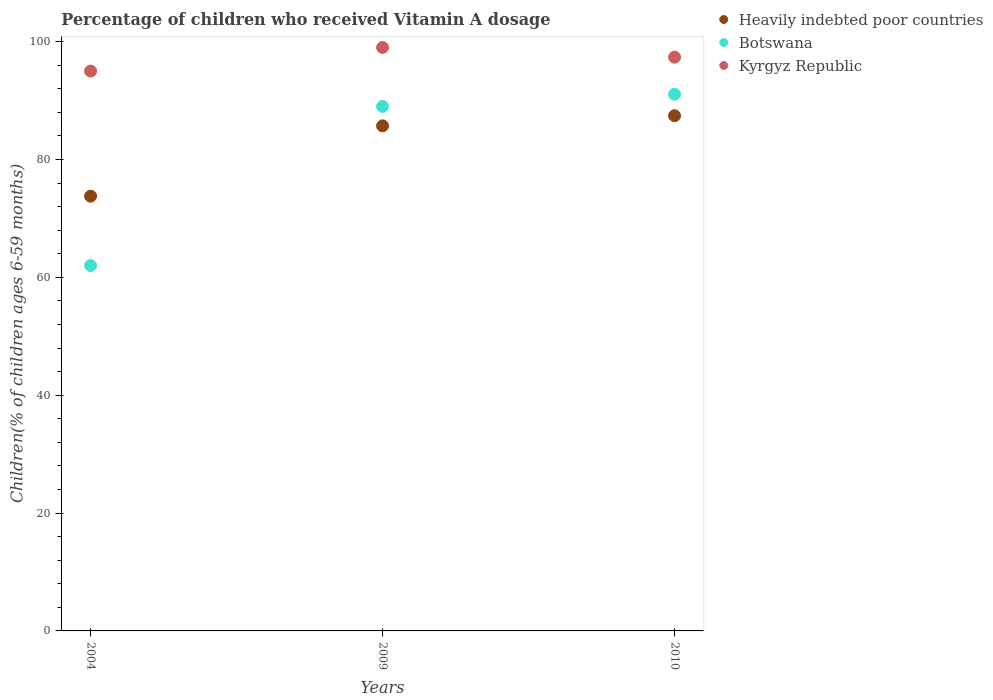Is the number of dotlines equal to the number of legend labels?
Keep it short and to the point. Yes. What is the percentage of children who received Vitamin A dosage in Heavily indebted poor countries in 2010?
Your answer should be very brief. 87.42. Across all years, what is the minimum percentage of children who received Vitamin A dosage in Botswana?
Offer a very short reply. 62. In which year was the percentage of children who received Vitamin A dosage in Botswana maximum?
Offer a very short reply. 2010. In which year was the percentage of children who received Vitamin A dosage in Kyrgyz Republic minimum?
Make the answer very short. 2004. What is the total percentage of children who received Vitamin A dosage in Heavily indebted poor countries in the graph?
Your response must be concise. 246.89. What is the difference between the percentage of children who received Vitamin A dosage in Heavily indebted poor countries in 2004 and that in 2009?
Give a very brief answer. -11.93. What is the difference between the percentage of children who received Vitamin A dosage in Heavily indebted poor countries in 2004 and the percentage of children who received Vitamin A dosage in Botswana in 2009?
Your answer should be very brief. -15.23. What is the average percentage of children who received Vitamin A dosage in Botswana per year?
Provide a succinct answer. 80.69. In the year 2009, what is the difference between the percentage of children who received Vitamin A dosage in Kyrgyz Republic and percentage of children who received Vitamin A dosage in Heavily indebted poor countries?
Make the answer very short. 13.3. What is the ratio of the percentage of children who received Vitamin A dosage in Heavily indebted poor countries in 2004 to that in 2010?
Ensure brevity in your answer.  0.84. What is the difference between the highest and the second highest percentage of children who received Vitamin A dosage in Botswana?
Your response must be concise. 2.06. What is the difference between the highest and the lowest percentage of children who received Vitamin A dosage in Botswana?
Keep it short and to the point. 29.06. In how many years, is the percentage of children who received Vitamin A dosage in Kyrgyz Republic greater than the average percentage of children who received Vitamin A dosage in Kyrgyz Republic taken over all years?
Give a very brief answer. 2. Is it the case that in every year, the sum of the percentage of children who received Vitamin A dosage in Heavily indebted poor countries and percentage of children who received Vitamin A dosage in Kyrgyz Republic  is greater than the percentage of children who received Vitamin A dosage in Botswana?
Your answer should be very brief. Yes. Is the percentage of children who received Vitamin A dosage in Botswana strictly greater than the percentage of children who received Vitamin A dosage in Heavily indebted poor countries over the years?
Your answer should be compact. No. Is the percentage of children who received Vitamin A dosage in Heavily indebted poor countries strictly less than the percentage of children who received Vitamin A dosage in Kyrgyz Republic over the years?
Offer a very short reply. Yes. How many years are there in the graph?
Your answer should be compact. 3. What is the difference between two consecutive major ticks on the Y-axis?
Make the answer very short. 20. Does the graph contain grids?
Provide a succinct answer. No. How are the legend labels stacked?
Your answer should be compact. Vertical. What is the title of the graph?
Your response must be concise. Percentage of children who received Vitamin A dosage. What is the label or title of the Y-axis?
Your response must be concise. Children(% of children ages 6-59 months). What is the Children(% of children ages 6-59 months) in Heavily indebted poor countries in 2004?
Your answer should be very brief. 73.77. What is the Children(% of children ages 6-59 months) in Botswana in 2004?
Your answer should be very brief. 62. What is the Children(% of children ages 6-59 months) in Heavily indebted poor countries in 2009?
Make the answer very short. 85.7. What is the Children(% of children ages 6-59 months) in Botswana in 2009?
Your response must be concise. 89. What is the Children(% of children ages 6-59 months) in Kyrgyz Republic in 2009?
Offer a very short reply. 99. What is the Children(% of children ages 6-59 months) of Heavily indebted poor countries in 2010?
Offer a very short reply. 87.42. What is the Children(% of children ages 6-59 months) in Botswana in 2010?
Your response must be concise. 91.06. What is the Children(% of children ages 6-59 months) of Kyrgyz Republic in 2010?
Provide a short and direct response. 97.35. Across all years, what is the maximum Children(% of children ages 6-59 months) of Heavily indebted poor countries?
Your answer should be very brief. 87.42. Across all years, what is the maximum Children(% of children ages 6-59 months) in Botswana?
Your answer should be compact. 91.06. Across all years, what is the maximum Children(% of children ages 6-59 months) of Kyrgyz Republic?
Your answer should be very brief. 99. Across all years, what is the minimum Children(% of children ages 6-59 months) in Heavily indebted poor countries?
Provide a succinct answer. 73.77. Across all years, what is the minimum Children(% of children ages 6-59 months) of Botswana?
Provide a succinct answer. 62. What is the total Children(% of children ages 6-59 months) in Heavily indebted poor countries in the graph?
Keep it short and to the point. 246.89. What is the total Children(% of children ages 6-59 months) of Botswana in the graph?
Provide a short and direct response. 242.06. What is the total Children(% of children ages 6-59 months) in Kyrgyz Republic in the graph?
Your response must be concise. 291.35. What is the difference between the Children(% of children ages 6-59 months) in Heavily indebted poor countries in 2004 and that in 2009?
Provide a succinct answer. -11.93. What is the difference between the Children(% of children ages 6-59 months) of Botswana in 2004 and that in 2009?
Provide a short and direct response. -27. What is the difference between the Children(% of children ages 6-59 months) of Heavily indebted poor countries in 2004 and that in 2010?
Keep it short and to the point. -13.65. What is the difference between the Children(% of children ages 6-59 months) of Botswana in 2004 and that in 2010?
Give a very brief answer. -29.06. What is the difference between the Children(% of children ages 6-59 months) of Kyrgyz Republic in 2004 and that in 2010?
Provide a short and direct response. -2.35. What is the difference between the Children(% of children ages 6-59 months) of Heavily indebted poor countries in 2009 and that in 2010?
Offer a terse response. -1.72. What is the difference between the Children(% of children ages 6-59 months) in Botswana in 2009 and that in 2010?
Make the answer very short. -2.06. What is the difference between the Children(% of children ages 6-59 months) in Kyrgyz Republic in 2009 and that in 2010?
Your response must be concise. 1.65. What is the difference between the Children(% of children ages 6-59 months) of Heavily indebted poor countries in 2004 and the Children(% of children ages 6-59 months) of Botswana in 2009?
Your answer should be very brief. -15.23. What is the difference between the Children(% of children ages 6-59 months) in Heavily indebted poor countries in 2004 and the Children(% of children ages 6-59 months) in Kyrgyz Republic in 2009?
Make the answer very short. -25.23. What is the difference between the Children(% of children ages 6-59 months) in Botswana in 2004 and the Children(% of children ages 6-59 months) in Kyrgyz Republic in 2009?
Provide a succinct answer. -37. What is the difference between the Children(% of children ages 6-59 months) of Heavily indebted poor countries in 2004 and the Children(% of children ages 6-59 months) of Botswana in 2010?
Offer a very short reply. -17.29. What is the difference between the Children(% of children ages 6-59 months) of Heavily indebted poor countries in 2004 and the Children(% of children ages 6-59 months) of Kyrgyz Republic in 2010?
Offer a very short reply. -23.58. What is the difference between the Children(% of children ages 6-59 months) of Botswana in 2004 and the Children(% of children ages 6-59 months) of Kyrgyz Republic in 2010?
Offer a very short reply. -35.35. What is the difference between the Children(% of children ages 6-59 months) of Heavily indebted poor countries in 2009 and the Children(% of children ages 6-59 months) of Botswana in 2010?
Your answer should be very brief. -5.36. What is the difference between the Children(% of children ages 6-59 months) of Heavily indebted poor countries in 2009 and the Children(% of children ages 6-59 months) of Kyrgyz Republic in 2010?
Provide a short and direct response. -11.66. What is the difference between the Children(% of children ages 6-59 months) in Botswana in 2009 and the Children(% of children ages 6-59 months) in Kyrgyz Republic in 2010?
Give a very brief answer. -8.35. What is the average Children(% of children ages 6-59 months) in Heavily indebted poor countries per year?
Ensure brevity in your answer.  82.3. What is the average Children(% of children ages 6-59 months) of Botswana per year?
Give a very brief answer. 80.69. What is the average Children(% of children ages 6-59 months) in Kyrgyz Republic per year?
Your answer should be very brief. 97.12. In the year 2004, what is the difference between the Children(% of children ages 6-59 months) in Heavily indebted poor countries and Children(% of children ages 6-59 months) in Botswana?
Offer a terse response. 11.77. In the year 2004, what is the difference between the Children(% of children ages 6-59 months) in Heavily indebted poor countries and Children(% of children ages 6-59 months) in Kyrgyz Republic?
Ensure brevity in your answer.  -21.23. In the year 2004, what is the difference between the Children(% of children ages 6-59 months) of Botswana and Children(% of children ages 6-59 months) of Kyrgyz Republic?
Offer a very short reply. -33. In the year 2009, what is the difference between the Children(% of children ages 6-59 months) of Heavily indebted poor countries and Children(% of children ages 6-59 months) of Botswana?
Make the answer very short. -3.3. In the year 2009, what is the difference between the Children(% of children ages 6-59 months) in Heavily indebted poor countries and Children(% of children ages 6-59 months) in Kyrgyz Republic?
Offer a very short reply. -13.3. In the year 2010, what is the difference between the Children(% of children ages 6-59 months) in Heavily indebted poor countries and Children(% of children ages 6-59 months) in Botswana?
Ensure brevity in your answer.  -3.64. In the year 2010, what is the difference between the Children(% of children ages 6-59 months) in Heavily indebted poor countries and Children(% of children ages 6-59 months) in Kyrgyz Republic?
Your answer should be very brief. -9.93. In the year 2010, what is the difference between the Children(% of children ages 6-59 months) in Botswana and Children(% of children ages 6-59 months) in Kyrgyz Republic?
Provide a short and direct response. -6.29. What is the ratio of the Children(% of children ages 6-59 months) of Heavily indebted poor countries in 2004 to that in 2009?
Provide a succinct answer. 0.86. What is the ratio of the Children(% of children ages 6-59 months) of Botswana in 2004 to that in 2009?
Provide a succinct answer. 0.7. What is the ratio of the Children(% of children ages 6-59 months) in Kyrgyz Republic in 2004 to that in 2009?
Provide a succinct answer. 0.96. What is the ratio of the Children(% of children ages 6-59 months) in Heavily indebted poor countries in 2004 to that in 2010?
Provide a succinct answer. 0.84. What is the ratio of the Children(% of children ages 6-59 months) in Botswana in 2004 to that in 2010?
Give a very brief answer. 0.68. What is the ratio of the Children(% of children ages 6-59 months) of Kyrgyz Republic in 2004 to that in 2010?
Give a very brief answer. 0.98. What is the ratio of the Children(% of children ages 6-59 months) of Heavily indebted poor countries in 2009 to that in 2010?
Provide a succinct answer. 0.98. What is the ratio of the Children(% of children ages 6-59 months) in Botswana in 2009 to that in 2010?
Keep it short and to the point. 0.98. What is the ratio of the Children(% of children ages 6-59 months) in Kyrgyz Republic in 2009 to that in 2010?
Your response must be concise. 1.02. What is the difference between the highest and the second highest Children(% of children ages 6-59 months) in Heavily indebted poor countries?
Your answer should be very brief. 1.72. What is the difference between the highest and the second highest Children(% of children ages 6-59 months) in Botswana?
Ensure brevity in your answer.  2.06. What is the difference between the highest and the second highest Children(% of children ages 6-59 months) in Kyrgyz Republic?
Give a very brief answer. 1.65. What is the difference between the highest and the lowest Children(% of children ages 6-59 months) of Heavily indebted poor countries?
Offer a very short reply. 13.65. What is the difference between the highest and the lowest Children(% of children ages 6-59 months) in Botswana?
Offer a terse response. 29.06. What is the difference between the highest and the lowest Children(% of children ages 6-59 months) of Kyrgyz Republic?
Give a very brief answer. 4. 